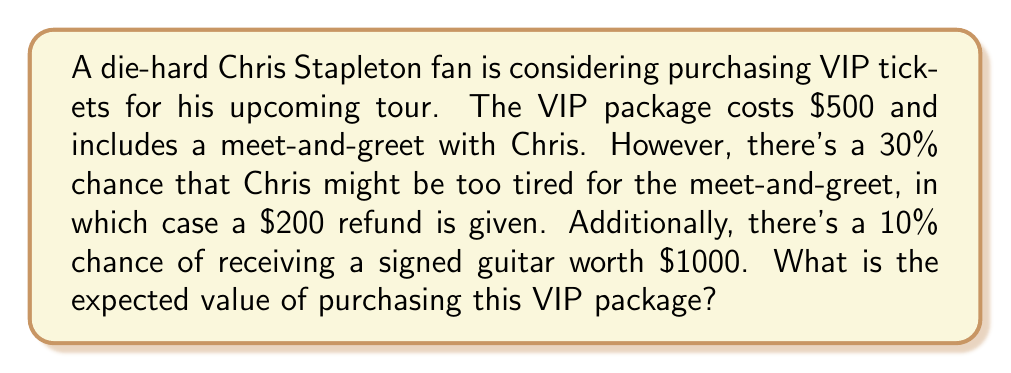Help me with this question. Let's approach this step-by-step:

1) First, let's define our events and their probabilities:
   - Let A be the event of Chris being available for the meet-and-greet: P(A) = 0.7
   - Let B be the event of Chris being too tired: P(B) = 0.3
   - Let C be the event of receiving a signed guitar: P(C) = 0.1

2) Now, let's calculate the value for each scenario:
   - If Chris is available and no guitar is received: $500
   - If Chris is tired and no guitar is received: $500 - $200 = $300
   - If a guitar is received (regardless of meet-and-greet): $500 + $1000 = $1500

3) The expected value is calculated by multiplying each outcome by its probability and summing:

   $$E = 500 \cdot P(A) \cdot (1-P(C)) + 300 \cdot P(B) \cdot (1-P(C)) + 1500 \cdot P(C)$$

4) Substituting the values:

   $$E = 500 \cdot 0.7 \cdot 0.9 + 300 \cdot 0.3 \cdot 0.9 + 1500 \cdot 0.1$$

5) Calculating:

   $$E = 315 + 81 + 150 = 546$$

Therefore, the expected value of purchasing the VIP package is $546.
Answer: $546 